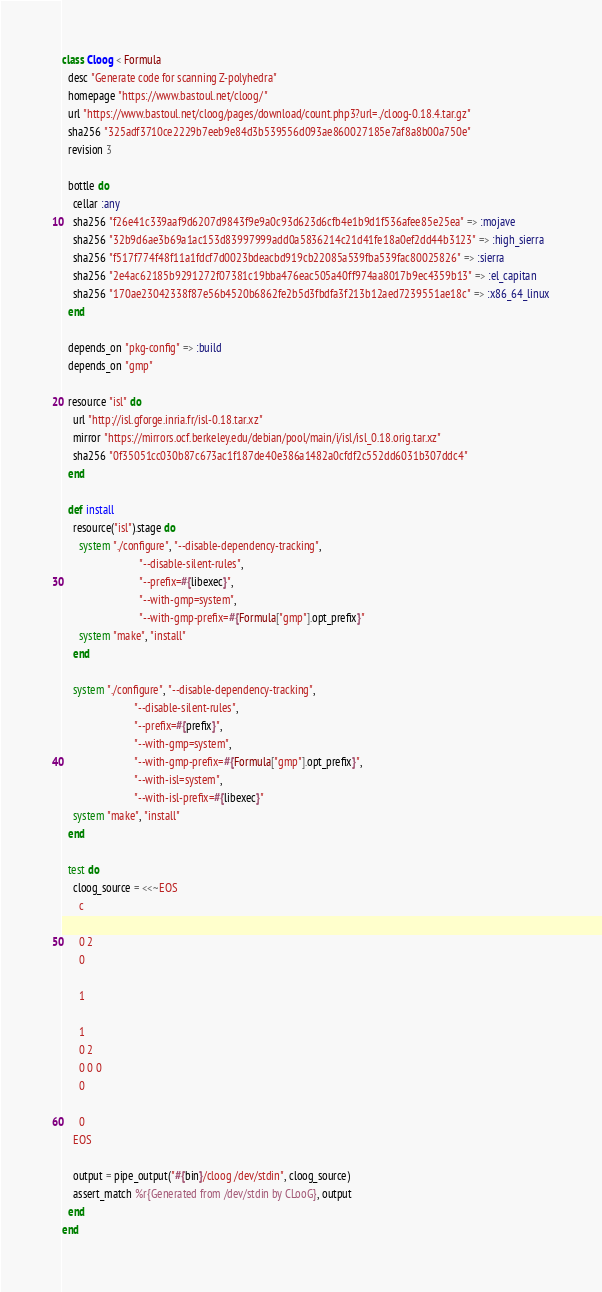<code> <loc_0><loc_0><loc_500><loc_500><_Ruby_>class Cloog < Formula
  desc "Generate code for scanning Z-polyhedra"
  homepage "https://www.bastoul.net/cloog/"
  url "https://www.bastoul.net/cloog/pages/download/count.php3?url=./cloog-0.18.4.tar.gz"
  sha256 "325adf3710ce2229b7eeb9e84d3b539556d093ae860027185e7af8a8b00a750e"
  revision 3

  bottle do
    cellar :any
    sha256 "f26e41c339aaf9d6207d9843f9e9a0c93d623d6cfb4e1b9d1f536afee85e25ea" => :mojave
    sha256 "32b9d6ae3b69a1ac153d83997999add0a5836214c21d41fe18a0ef2dd44b3123" => :high_sierra
    sha256 "f517f774f48f11a1fdcf7d0023bdeacbd919cb22085a539fba539fac80025826" => :sierra
    sha256 "2e4ac62185b9291272f07381c19bba476eac505a40ff974aa8017b9ec4359b13" => :el_capitan
    sha256 "170ae23042338f87e56b4520b6862fe2b5d3fbdfa3f213b12aed7239551ae18c" => :x86_64_linux
  end

  depends_on "pkg-config" => :build
  depends_on "gmp"

  resource "isl" do
    url "http://isl.gforge.inria.fr/isl-0.18.tar.xz"
    mirror "https://mirrors.ocf.berkeley.edu/debian/pool/main/i/isl/isl_0.18.orig.tar.xz"
    sha256 "0f35051cc030b87c673ac1f187de40e386a1482a0cfdf2c552dd6031b307ddc4"
  end

  def install
    resource("isl").stage do
      system "./configure", "--disable-dependency-tracking",
                            "--disable-silent-rules",
                            "--prefix=#{libexec}",
                            "--with-gmp=system",
                            "--with-gmp-prefix=#{Formula["gmp"].opt_prefix}"
      system "make", "install"
    end

    system "./configure", "--disable-dependency-tracking",
                          "--disable-silent-rules",
                          "--prefix=#{prefix}",
                          "--with-gmp=system",
                          "--with-gmp-prefix=#{Formula["gmp"].opt_prefix}",
                          "--with-isl=system",
                          "--with-isl-prefix=#{libexec}"
    system "make", "install"
  end

  test do
    cloog_source = <<~EOS
      c

      0 2
      0

      1

      1
      0 2
      0 0 0
      0

      0
    EOS

    output = pipe_output("#{bin}/cloog /dev/stdin", cloog_source)
    assert_match %r{Generated from /dev/stdin by CLooG}, output
  end
end
</code> 